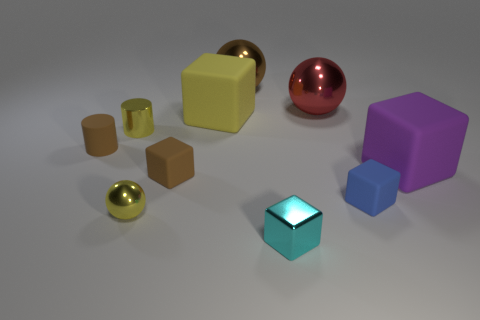What number of blue things are the same shape as the brown shiny thing?
Provide a short and direct response. 0. There is a cube that is the same color as the tiny metal ball; what is it made of?
Ensure brevity in your answer.  Rubber. How many objects are brown metal spheres or objects that are in front of the purple matte cube?
Your answer should be very brief. 5. What is the material of the blue object?
Your answer should be very brief. Rubber. There is a brown object that is the same shape as the big red metallic thing; what is it made of?
Your answer should be very brief. Metal. There is a big sphere that is behind the large shiny sphere that is on the right side of the cyan thing; what is its color?
Keep it short and to the point. Brown. How many matte things are tiny gray things or big cubes?
Your response must be concise. 2. Do the big brown thing and the big purple thing have the same material?
Give a very brief answer. No. What is the material of the small thing that is right of the large sphere that is on the right side of the large brown metallic ball?
Make the answer very short. Rubber. How many small things are purple rubber things or blue rubber objects?
Give a very brief answer. 1. 